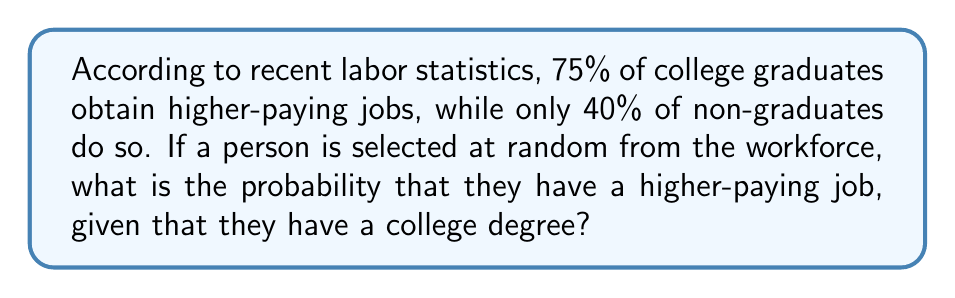Could you help me with this problem? Let's approach this step-by-step using Bayes' theorem:

1) Define events:
   A: Person has a higher-paying job
   B: Person has a college degree

2) Given probabilities:
   $P(A|B) = 0.75$ (probability of higher-paying job given college degree)
   $P(A|\text{not }B) = 0.40$ (probability of higher-paying job without college degree)

3) We're asked to find $P(A|B)$, which we already know is 0.75.

4) To understand why this is the answer, let's break it down using Bayes' theorem:

   $$P(A|B) = \frac{P(B|A) \cdot P(A)}{P(B)}$$

5) However, we don't need to calculate this because we're given $P(A|B)$ directly.

6) This probability (0.75 or 75%) represents the likelihood that a person with a college degree will have a higher-paying job.

7) Comparing this to the 40% chance for non-graduates, we can see that having a college degree increases the probability of obtaining a higher-paying job by 35 percentage points.
Answer: 0.75 or 75% 